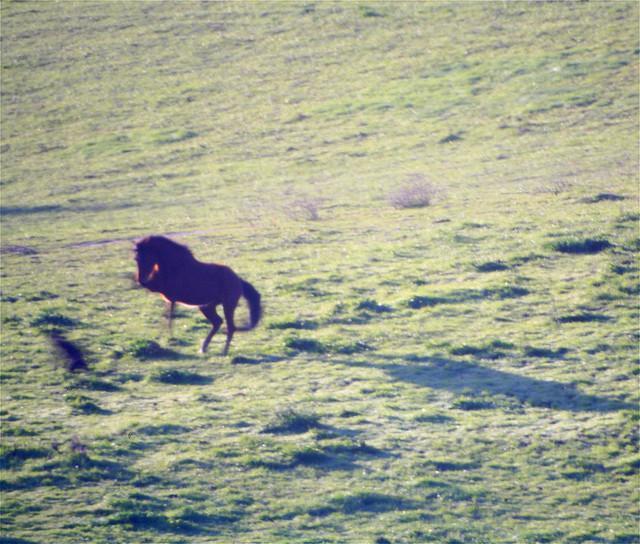How many people are there?
Give a very brief answer. 0. How many chairs are there?
Give a very brief answer. 0. 